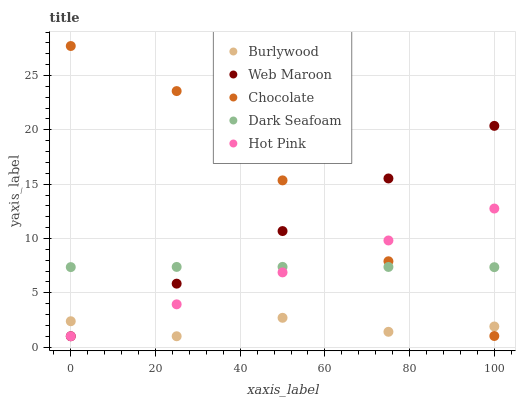Does Burlywood have the minimum area under the curve?
Answer yes or no. Yes. Does Chocolate have the maximum area under the curve?
Answer yes or no. Yes. Does Dark Seafoam have the minimum area under the curve?
Answer yes or no. No. Does Dark Seafoam have the maximum area under the curve?
Answer yes or no. No. Is Hot Pink the smoothest?
Answer yes or no. Yes. Is Burlywood the roughest?
Answer yes or no. Yes. Is Dark Seafoam the smoothest?
Answer yes or no. No. Is Dark Seafoam the roughest?
Answer yes or no. No. Does Burlywood have the lowest value?
Answer yes or no. Yes. Does Dark Seafoam have the lowest value?
Answer yes or no. No. Does Chocolate have the highest value?
Answer yes or no. Yes. Does Dark Seafoam have the highest value?
Answer yes or no. No. Is Burlywood less than Dark Seafoam?
Answer yes or no. Yes. Is Dark Seafoam greater than Burlywood?
Answer yes or no. Yes. Does Hot Pink intersect Burlywood?
Answer yes or no. Yes. Is Hot Pink less than Burlywood?
Answer yes or no. No. Is Hot Pink greater than Burlywood?
Answer yes or no. No. Does Burlywood intersect Dark Seafoam?
Answer yes or no. No. 